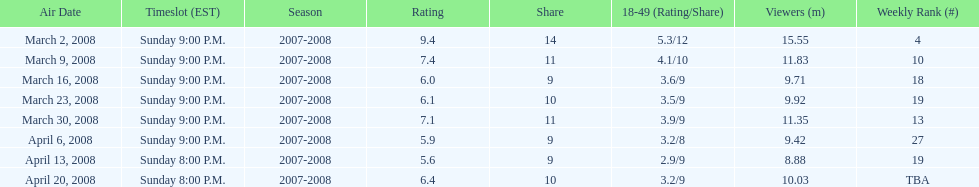How many shows had at least 10 million viewers? 4. 